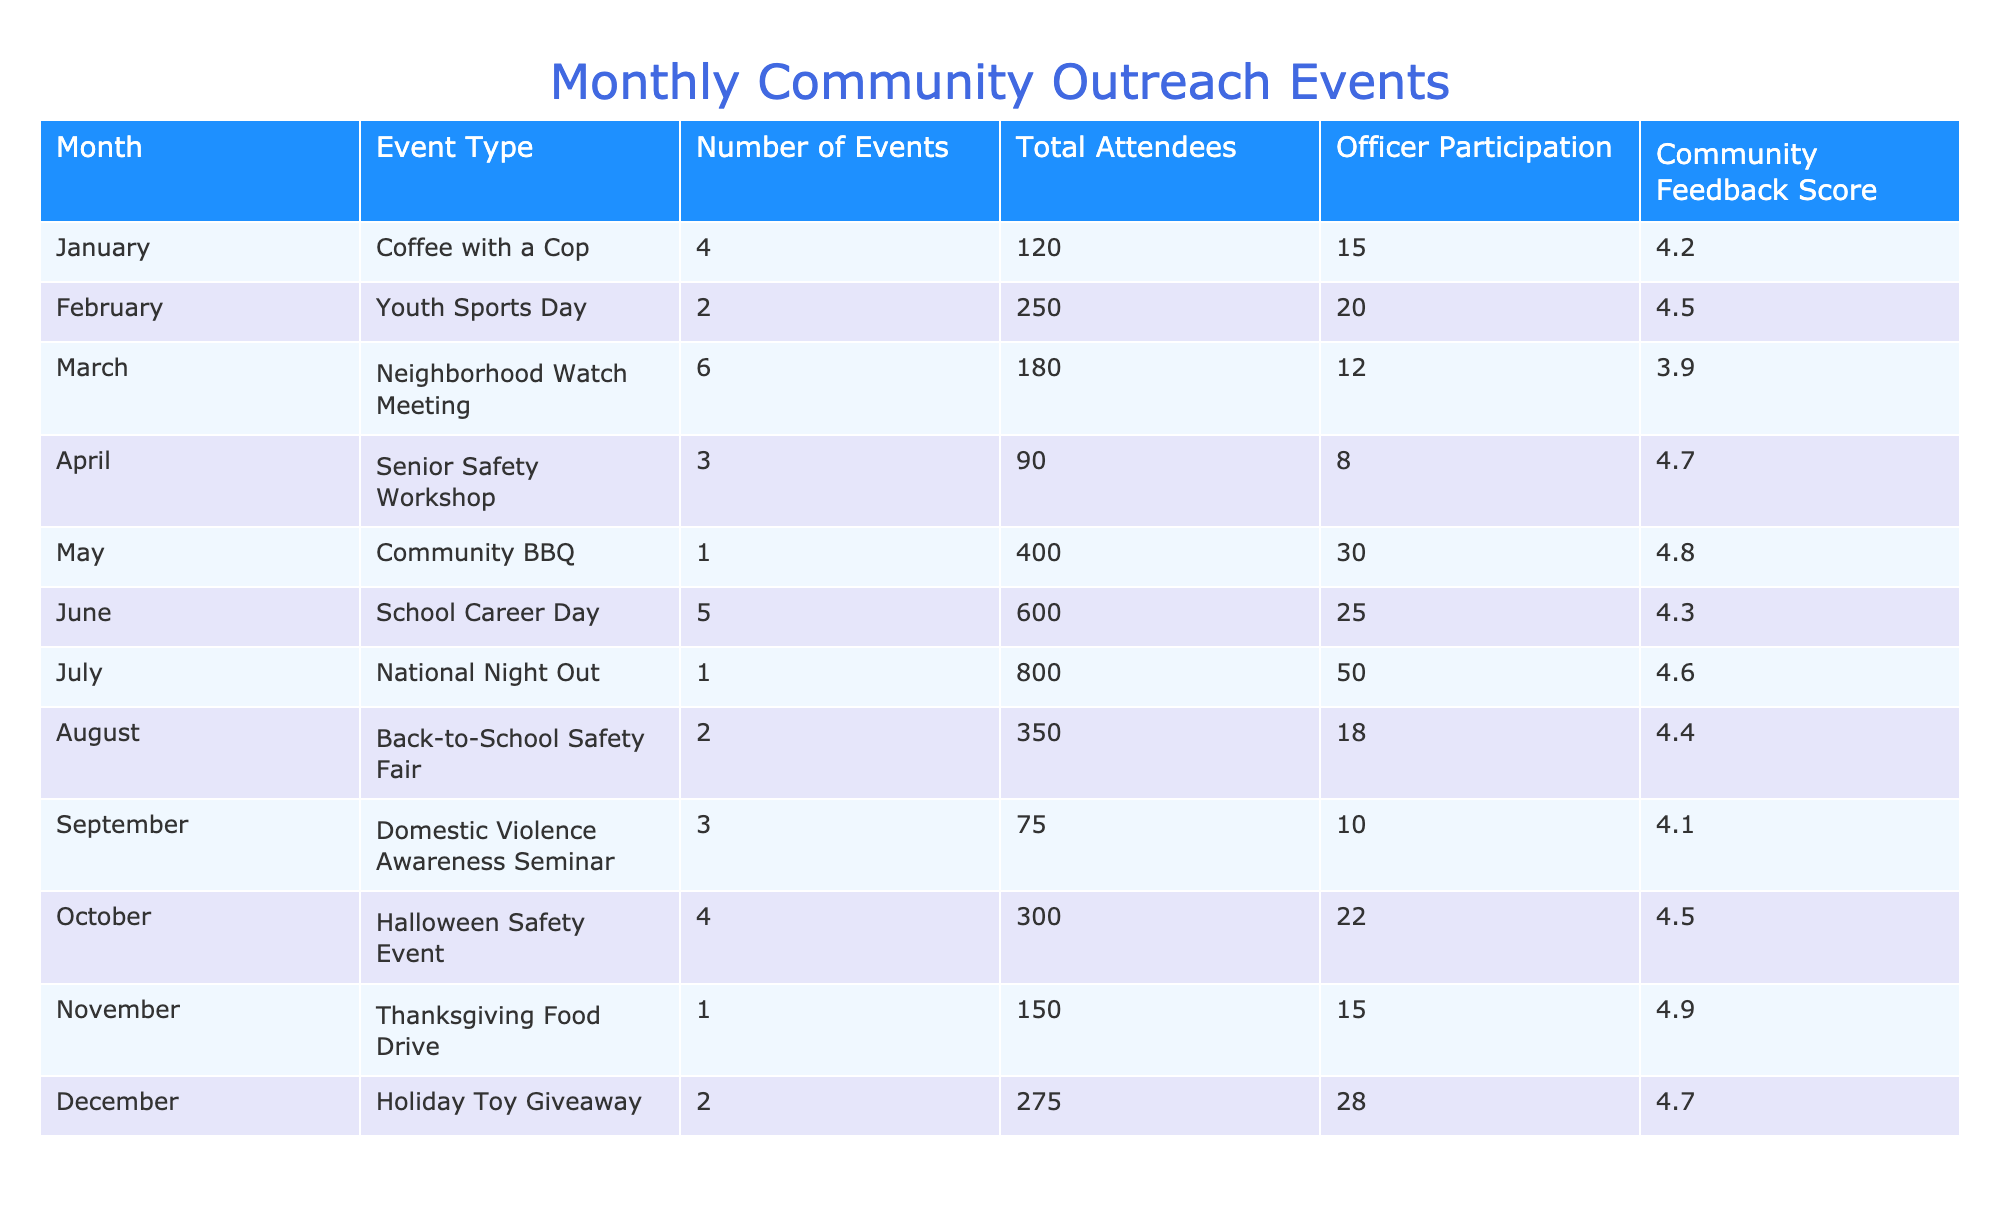What was the highest number of attendees at an event? Looking at the "Total Attendees" column, the event with the highest number is the "National Night Out" in July, which had 800 attendees.
Answer: 800 How many events were held in March? According to the "Number of Events" for March, there were 6 events.
Answer: 6 What is the average Community Feedback Score for the events held between January and June? The scores from January to June are 4.2, 4.5, 3.9, 4.7, 4.8, and 4.3. Adding these scores gives 26.4. Dividing by 6 (the number of events) yields an average score of 4.4.
Answer: 4.4 Did the "Community BBQ" have more officer participation or attendees? The "Community BBQ" had 30 officer participants but 400 attendees. Since 400 > 30, the attendees were higher.
Answer: Yes Which month had the highest officer participation and what was the score for that event? A comparison across officer participation shows that "National Night Out" in July had the highest with 50 officers participating, and that event had a feedback score of 4.6.
Answer: July, 4.6 How many more total attendees were there in June compared to September? June had 600 attendees and September had 75 attendees. The difference is 600 - 75 = 525.
Answer: 525 What event type had the lowest Community Feedback Score and what was it? The "Neighborhood Watch Meeting" in March had the lowest score of 3.9.
Answer: Neighborhood Watch Meeting, 3.9 How many total events were held throughout the year? To find the total number of events, sum the "Number of Events" for all months: 4 + 2 + 6 + 3 + 1 + 5 + 1 + 2 + 3 + 4 + 1 + 2 = 35.
Answer: 35 